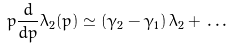Convert formula to latex. <formula><loc_0><loc_0><loc_500><loc_500>p \frac { d } { d p } \lambda _ { 2 } ( p ) \simeq \left ( \gamma _ { 2 } - \gamma _ { 1 } \right ) \lambda _ { 2 } + \, \dots</formula> 